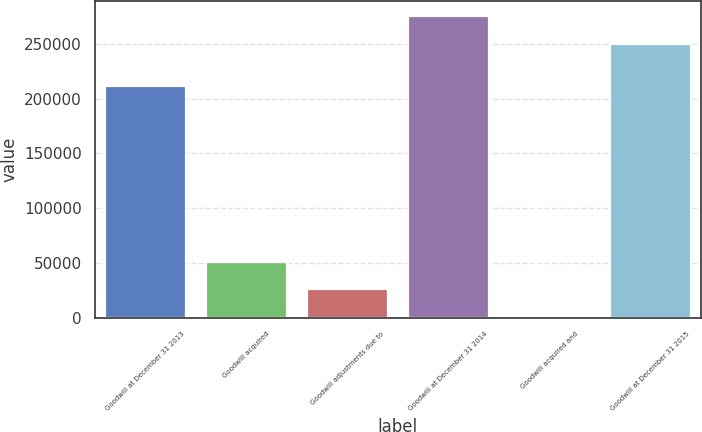Convert chart to OTSL. <chart><loc_0><loc_0><loc_500><loc_500><bar_chart><fcel>Goodwill at December 31 2013<fcel>Goodwill acquired<fcel>Goodwill adjustments due to<fcel>Goodwill at December 31 2014<fcel>Goodwill acquired and<fcel>Goodwill at December 31 2015<nl><fcel>211847<fcel>51269.4<fcel>25732.7<fcel>275476<fcel>196<fcel>249939<nl></chart> 